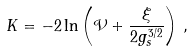<formula> <loc_0><loc_0><loc_500><loc_500>K = - 2 \ln \left ( \mathcal { V } + \frac { \xi } { 2 g _ { s } ^ { 3 / 2 } } \right ) \, ,</formula> 